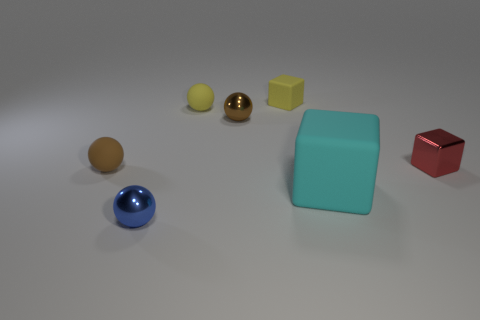Add 1 large matte objects. How many objects exist? 8 Subtract all cyan blocks. Subtract all blue balls. How many blocks are left? 2 Subtract all balls. How many objects are left? 3 Add 4 large shiny objects. How many large shiny objects exist? 4 Subtract 0 green balls. How many objects are left? 7 Subtract all matte balls. Subtract all metal blocks. How many objects are left? 4 Add 1 tiny blue objects. How many tiny blue objects are left? 2 